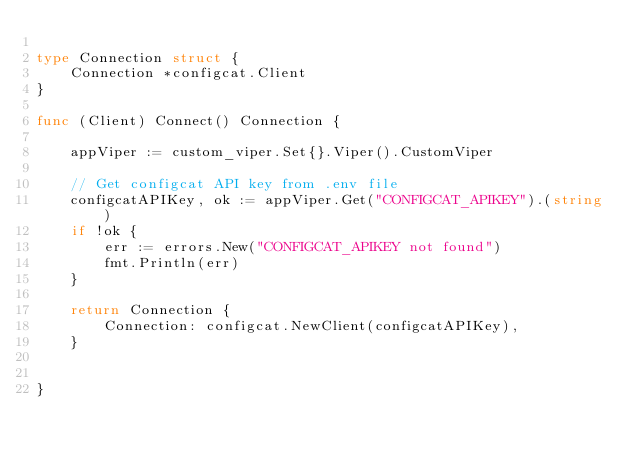Convert code to text. <code><loc_0><loc_0><loc_500><loc_500><_Go_>
type Connection struct {
	Connection *configcat.Client
}

func (Client) Connect() Connection {

	appViper := custom_viper.Set{}.Viper().CustomViper

	// Get configcat API key from .env file
	configcatAPIKey, ok := appViper.Get("CONFIGCAT_APIKEY").(string)
	if !ok {
		err := errors.New("CONFIGCAT_APIKEY not found")
		fmt.Println(err)
	}
	
	return Connection {
		Connection: configcat.NewClient(configcatAPIKey), 
	}
	

}

</code> 